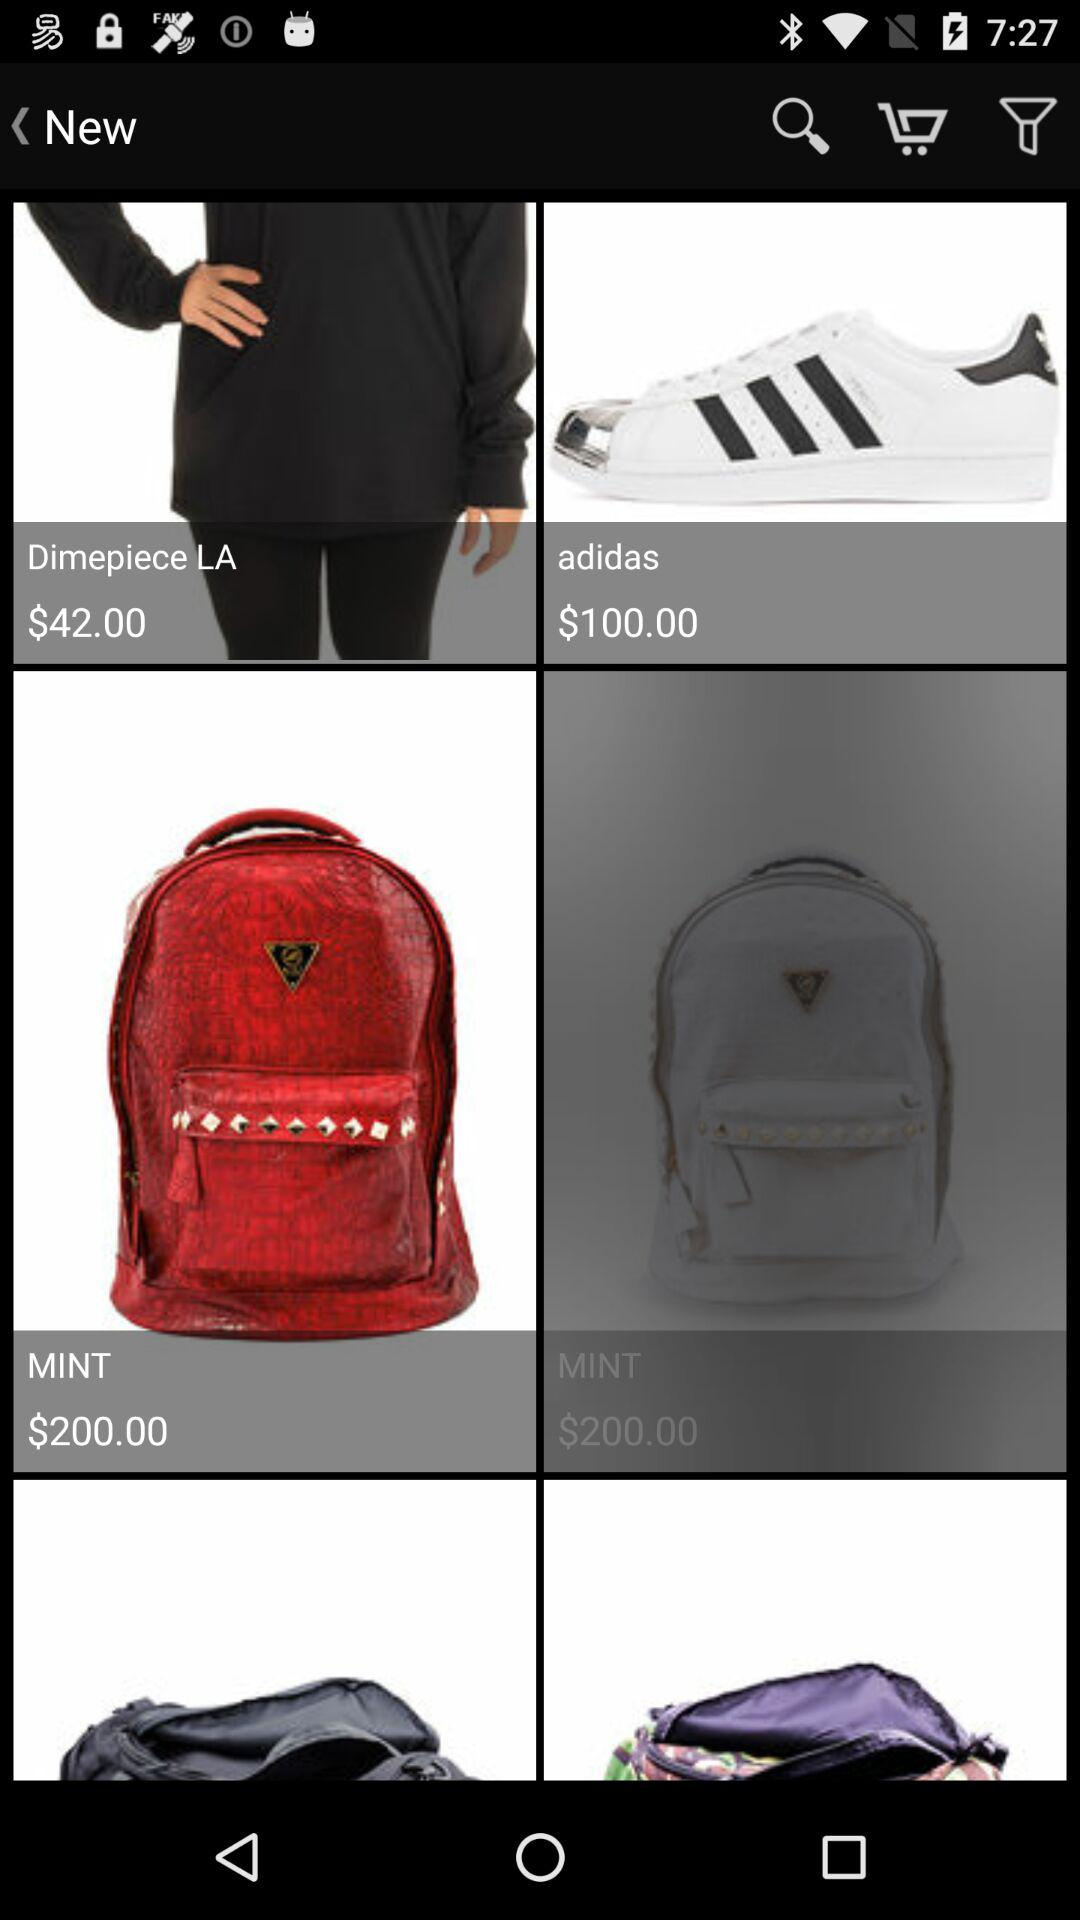What is the price of the "Dimepiece LA" product? The price is $42. 